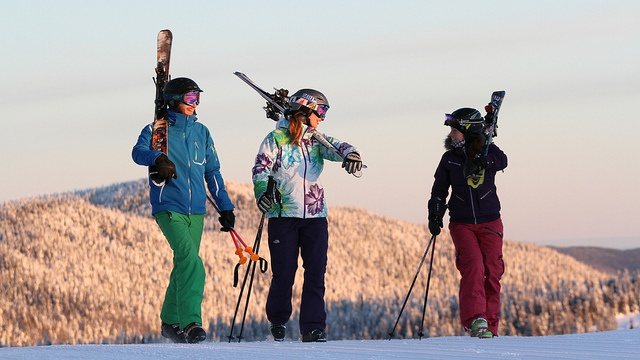Describe the objects in this image and their specific colors. I can see people in lightblue, black, lightgray, gray, and darkgray tones, people in lightblue, teal, black, and darkgreen tones, people in lightgray, black, maroon, gray, and brown tones, skis in lightgray, black, maroon, gray, and brown tones, and skis in lightgray, black, gray, olive, and navy tones in this image. 